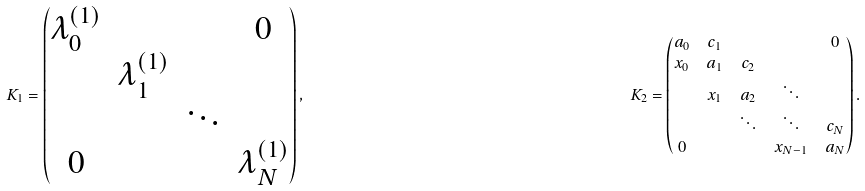Convert formula to latex. <formula><loc_0><loc_0><loc_500><loc_500>K _ { 1 } = \begin{pmatrix} \lambda _ { 0 } ^ { ( 1 ) } & & & 0 \\ & \lambda _ { 1 } ^ { ( 1 ) } & & \\ & & \ddots & \\ 0 & & & \lambda _ { N } ^ { ( 1 ) } \end{pmatrix} , & & K _ { 2 } = \begin{pmatrix} a _ { 0 } & c _ { 1 } & & & 0 \\ x _ { 0 } & a _ { 1 } & c _ { 2 } & & \\ & x _ { 1 } & a _ { 2 } & \ddots & \\ & & \ddots & \ddots & c _ { N } \\ 0 & & & x _ { N - 1 } & a _ { N } \end{pmatrix} .</formula> 